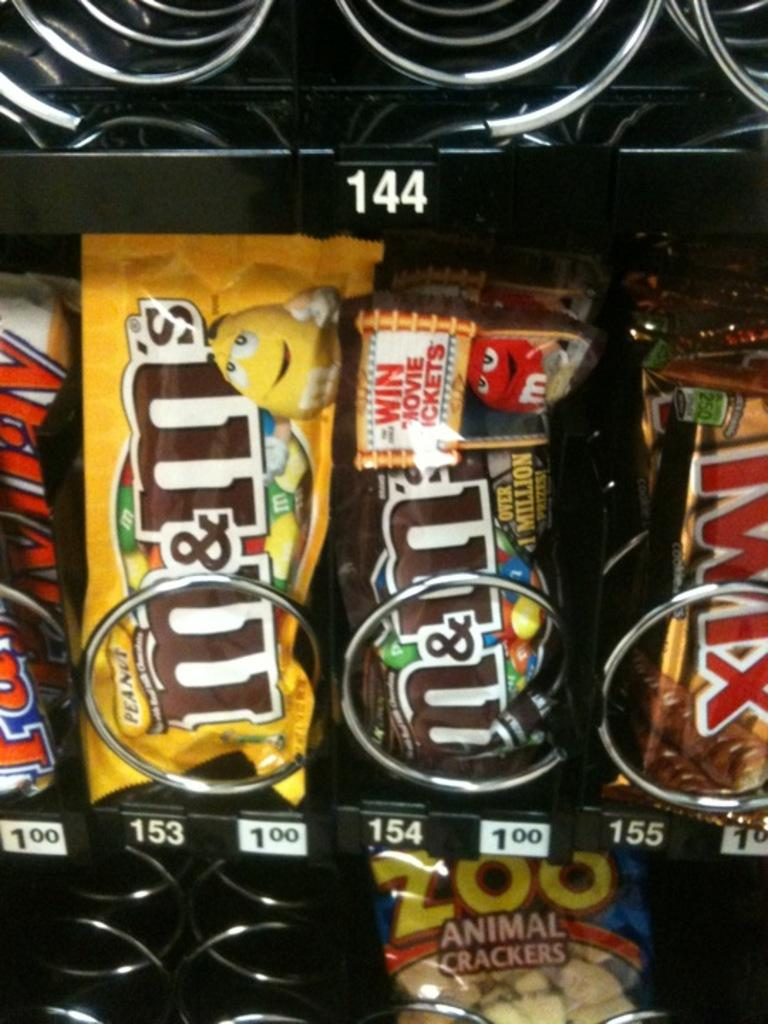What type of food items can be seen in the image? There are chocolates and cookies in the image. Where are the chocolates and cookies located? The chocolates and cookies are kept in the racks of a vending machine. What type of fuel can be seen in the image? There is no fuel present in the image; it features chocolates and cookies in a vending machine. Can you see a rat in the image? There is no rat present in the image. 